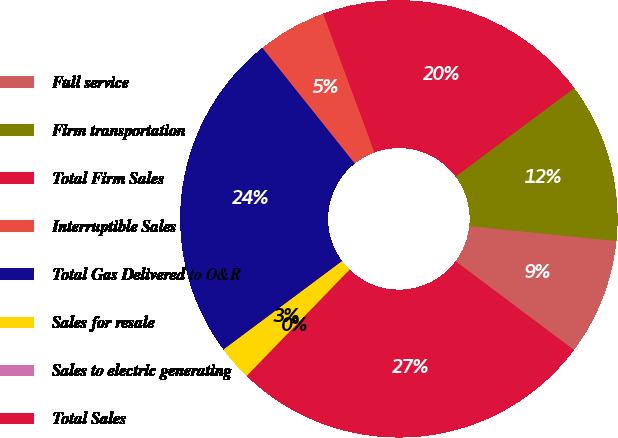<chart> <loc_0><loc_0><loc_500><loc_500><pie_chart><fcel>Full service<fcel>Firm transportation<fcel>Total Firm Sales<fcel>Interruptible Sales<fcel>Total Gas Delivered to O&R<fcel>Sales for resale<fcel>Sales to electric generating<fcel>Total Sales<nl><fcel>8.62%<fcel>11.81%<fcel>20.44%<fcel>5.09%<fcel>24.47%<fcel>2.55%<fcel>0.02%<fcel>27.0%<nl></chart> 